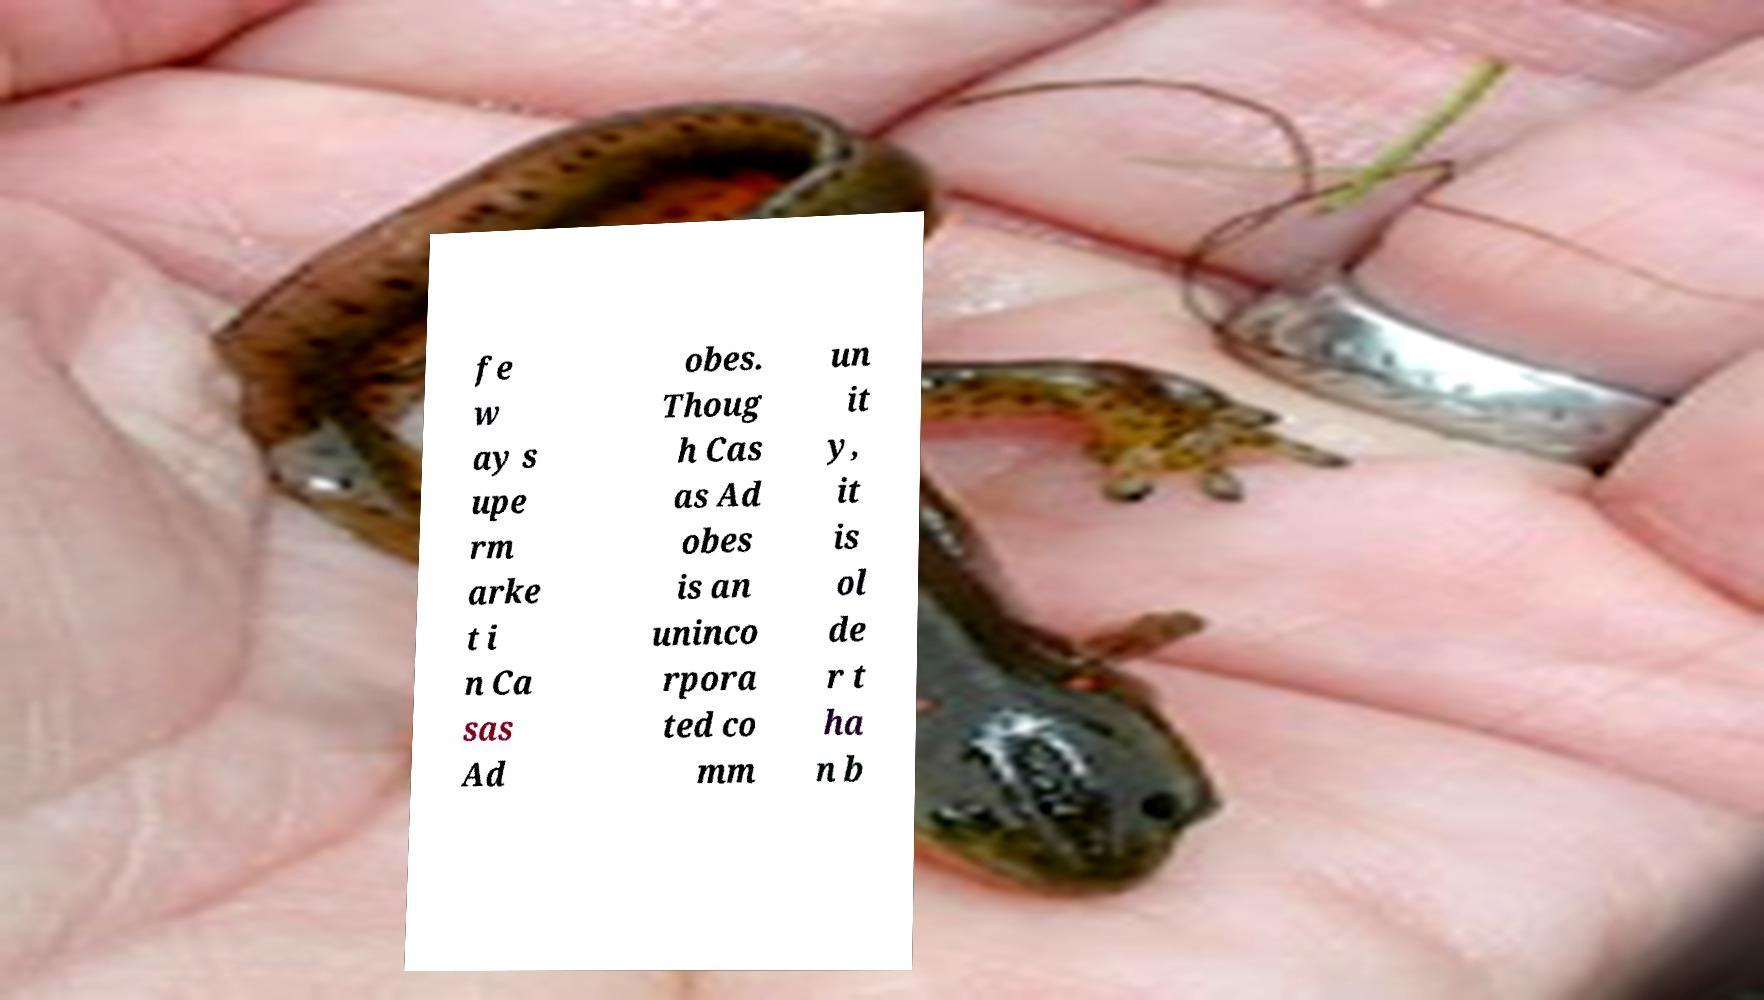Could you extract and type out the text from this image? fe w ay s upe rm arke t i n Ca sas Ad obes. Thoug h Cas as Ad obes is an uninco rpora ted co mm un it y, it is ol de r t ha n b 